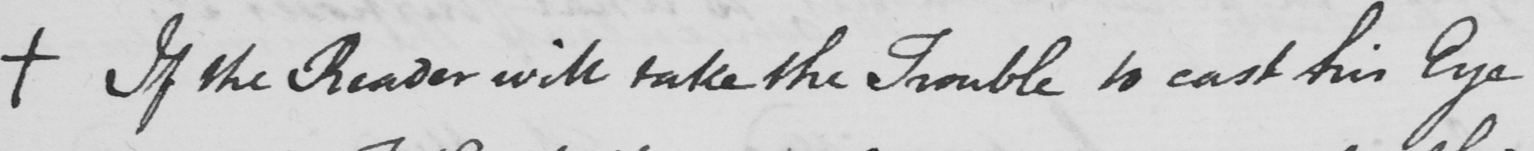What does this handwritten line say? +  If the reader will take the Trouble to cast his Eye 